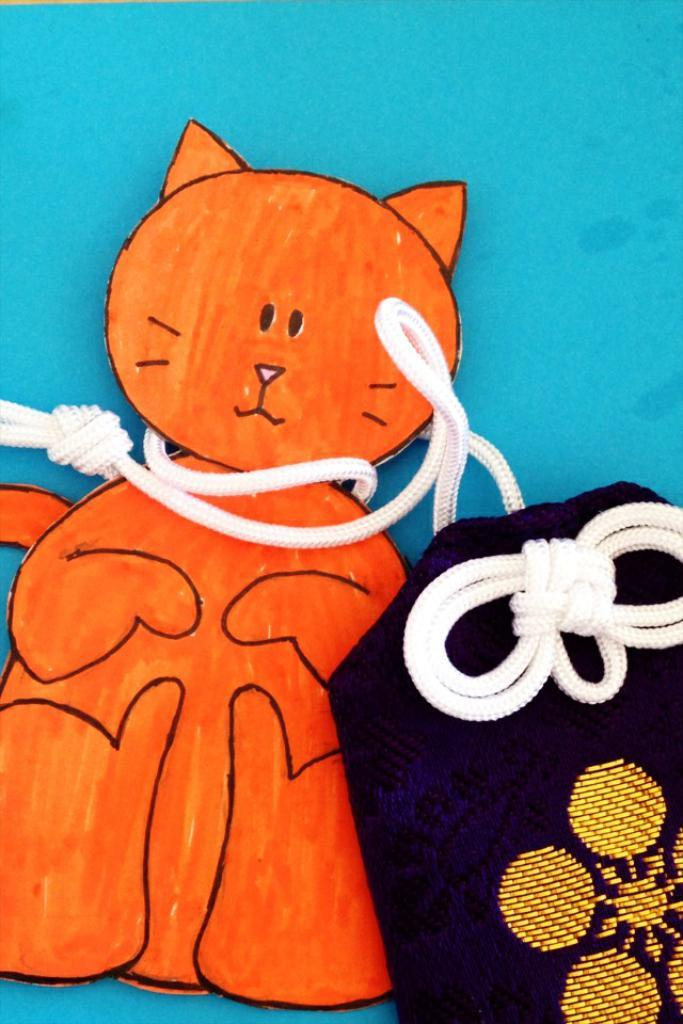What is the main subject of the image? The main subject of the image is a paper cat. How is the paper cat secured in the image? The paper cat is tied with ropes. What is the paper cat attached to in the image? The paper cat is attached to a pouch. Can you describe the object that the pouch is on? The pouch is on an object, but the specific object is not mentioned in the facts. What type of cracker is being used to hold the paper cat in place? There is no cracker present in the image; the paper cat is tied with ropes. 